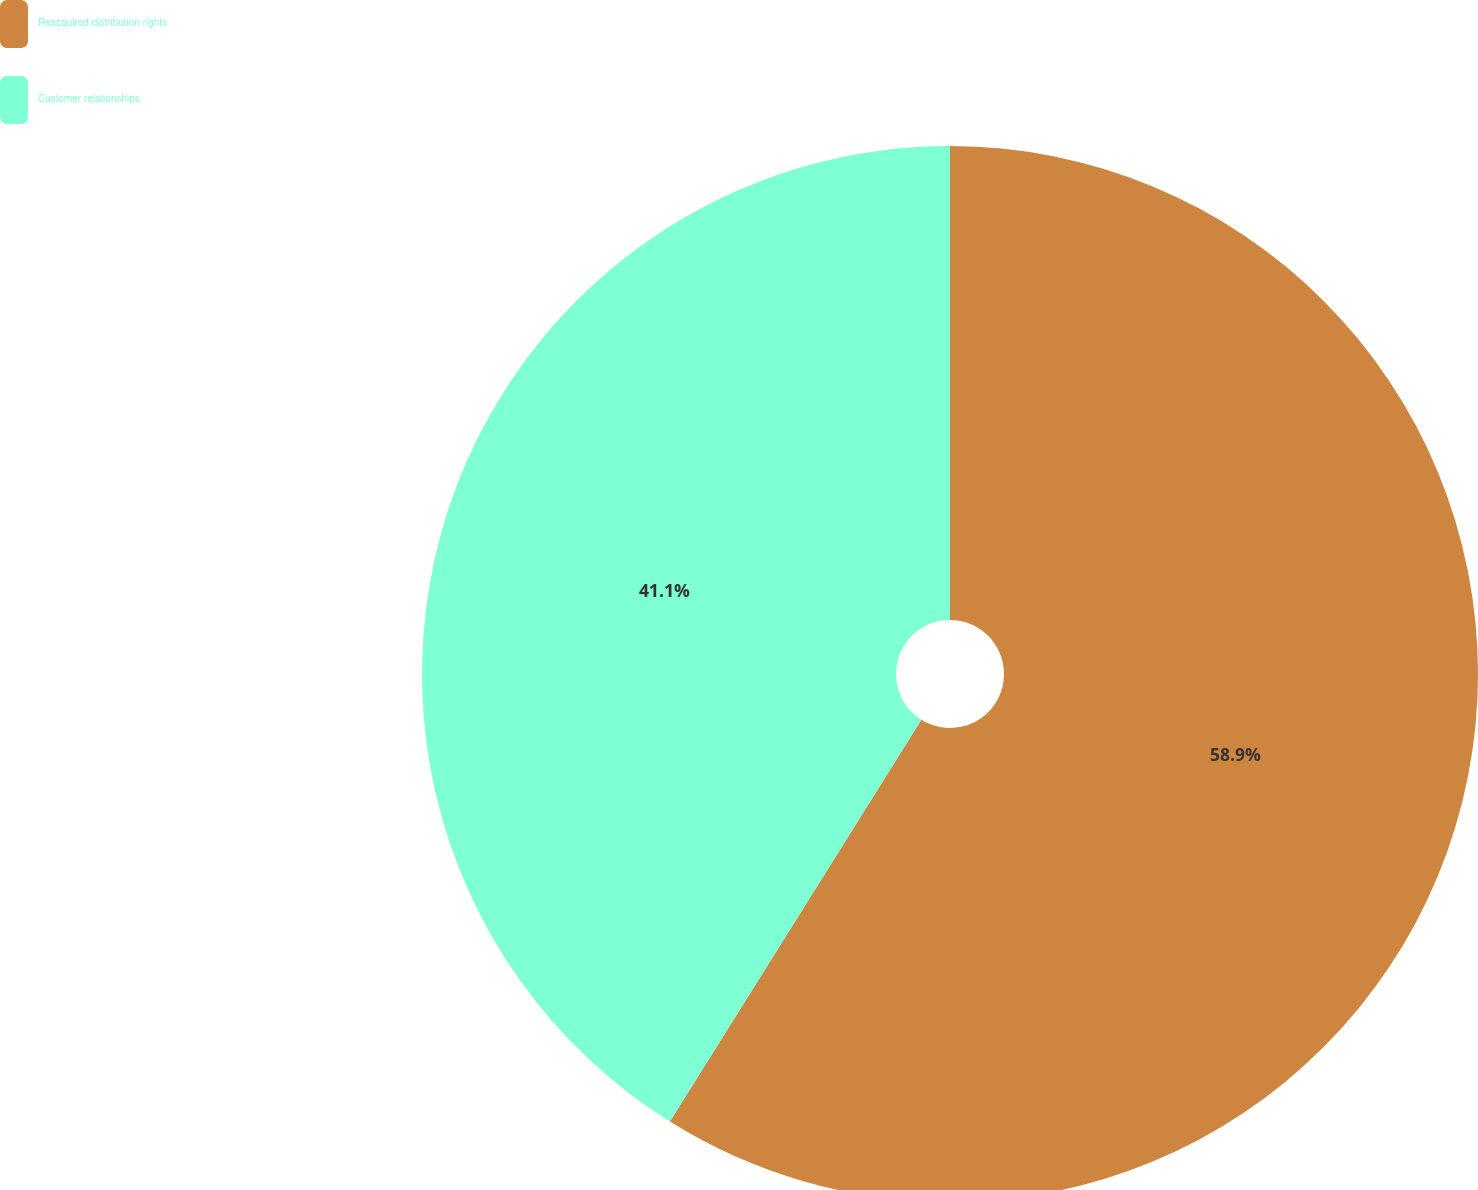Convert chart to OTSL. <chart><loc_0><loc_0><loc_500><loc_500><pie_chart><fcel>Reacquired distribution rights<fcel>Customer relationships<nl><fcel>58.9%<fcel>41.1%<nl></chart> 